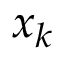<formula> <loc_0><loc_0><loc_500><loc_500>{ x } _ { k }</formula> 